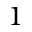Convert formula to latex. <formula><loc_0><loc_0><loc_500><loc_500>1</formula> 